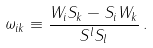Convert formula to latex. <formula><loc_0><loc_0><loc_500><loc_500>\omega _ { i k } \equiv \frac { W _ { i } S _ { k } - S _ { i } W _ { k } } { S ^ { l } S _ { l } } \, .</formula> 